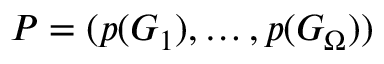<formula> <loc_0><loc_0><loc_500><loc_500>P = ( p ( G _ { 1 } ) , \dots , p ( G _ { \Omega } ) )</formula> 